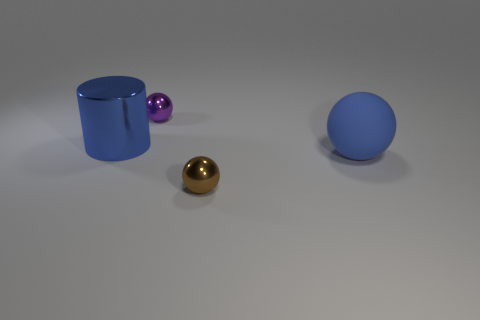Can you speculate on the material and texture of the surfaces we're seeing? The cylindrical container looks to have a smooth, glossy finish, indicative of a metallic or plastic material. The spheres all have a reflective surface, hinting at either a metallic or glass-like texture. Their reflections and highlights suggest a smooth and polished surface. The ground plane has a matte finish, possibly resembling a solid, non-reflective material like stone or untreated metal. 